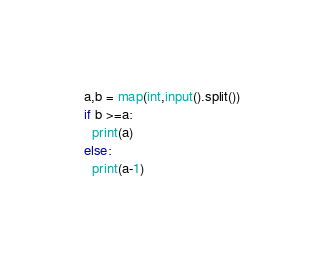Convert code to text. <code><loc_0><loc_0><loc_500><loc_500><_Python_>a,b = map(int,input().split())
if b >=a:
  print(a)
else:
  print(a-1)</code> 